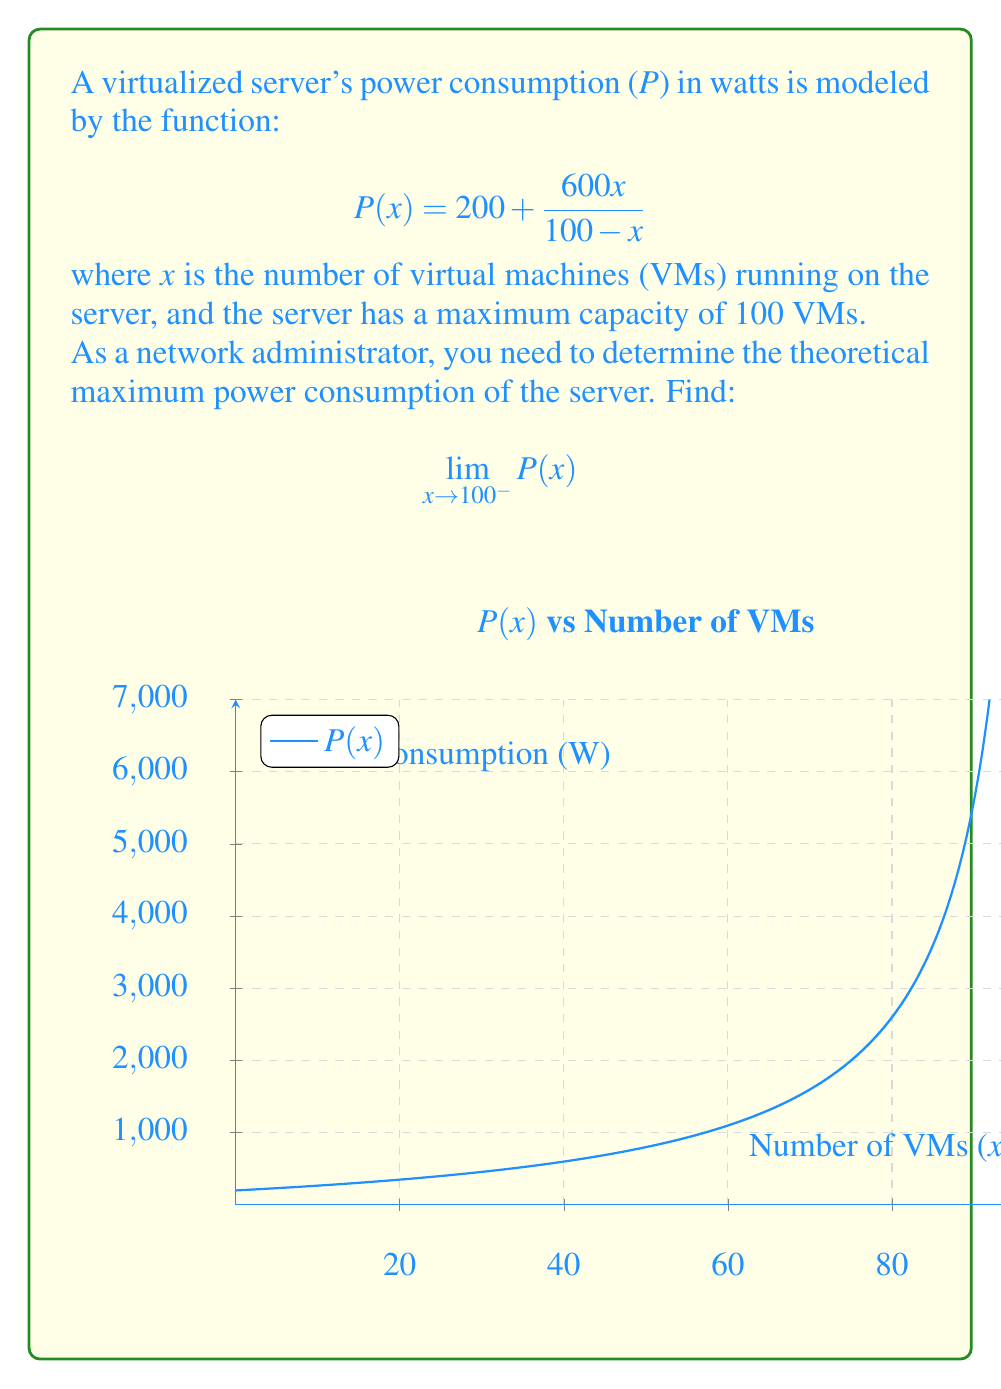Can you answer this question? To find the limit as x approaches 100 from the left side, let's follow these steps:

1) First, let's examine the function:
   $$P(x) = 200 + \frac{600x}{100-x}$$

2) As x approaches 100, the denominator (100-x) approaches 0. This suggests we might have a vertical asymptote.

3) Let's try to simplify the fraction:
   $$\frac{600x}{100-x} = \frac{-600x}{x-100}$$

4) Now our function looks like:
   $$P(x) = 200 - \frac{600x}{x-100}$$

5) As x approaches 100, the numerator approaches -60000, while the denominator approaches 0.

6) In limit notation:
   $$\lim_{x \to 100^-} P(x) = 200 + \lim_{x \to 100^-} \frac{-600x}{x-100}$$

7) The limit of the fraction part is of the form $\frac{-\infty}{0^-}$, which equals positive infinity.

8) Therefore:
   $$\lim_{x \to 100^-} P(x) = 200 + (+\infty) = +\infty$$

This means that as the number of VMs approaches the server's maximum capacity, the power consumption theoretically approaches infinity.
Answer: $+\infty$ 